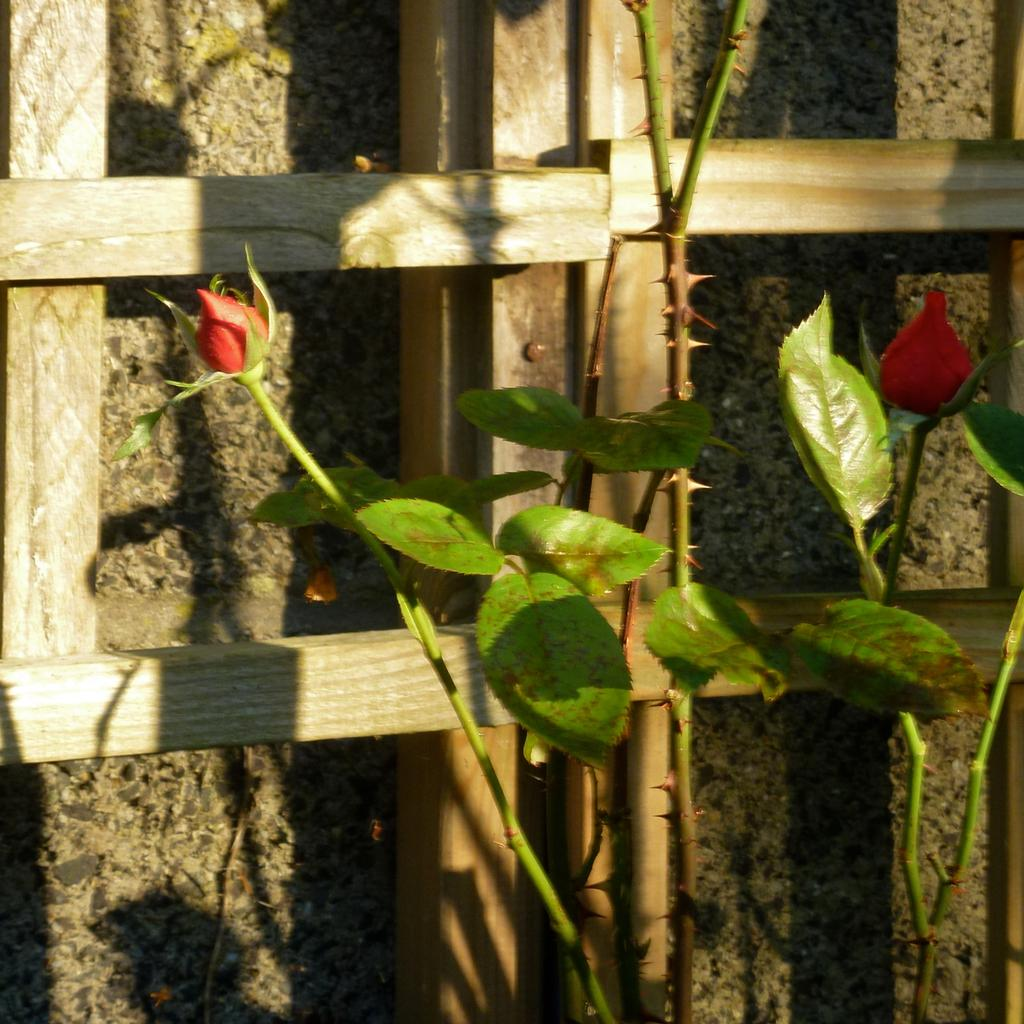What type of living organism can be seen in the image? There is a plant in the image. What can be seen in the background of the image? There are wooden sticks and a wall in the background of the image. How many red flowers are present in the image? There are two red flowers in the image. Where can the mice be seen playing in the image? There are no mice present in the image. What type of sock is hanging on the wall in the image? There is no sock present in the image. 